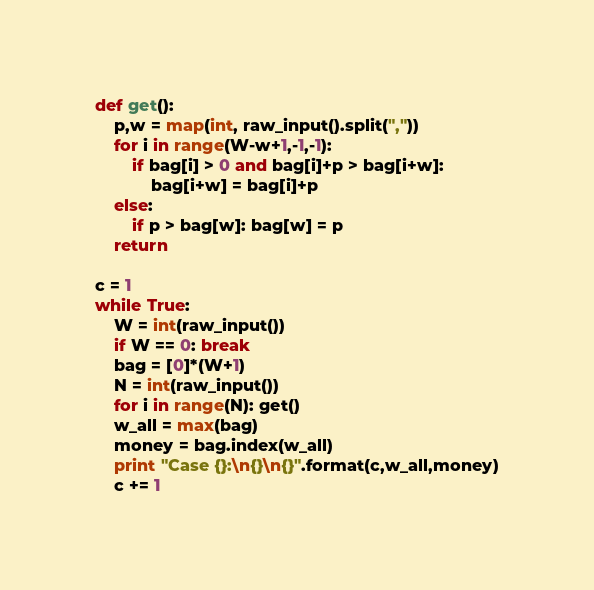Convert code to text. <code><loc_0><loc_0><loc_500><loc_500><_Python_>def get():
	p,w = map(int, raw_input().split(","))
	for i in range(W-w+1,-1,-1):
		if bag[i] > 0 and bag[i]+p > bag[i+w]:
			bag[i+w] = bag[i]+p
	else:
		if p > bag[w]: bag[w] = p
	return

c = 1
while True:
	W = int(raw_input())
	if W == 0: break
	bag = [0]*(W+1)
	N = int(raw_input())
	for i in range(N): get()
	w_all = max(bag)
	money = bag.index(w_all)
	print "Case {}:\n{}\n{}".format(c,w_all,money)
	c += 1</code> 